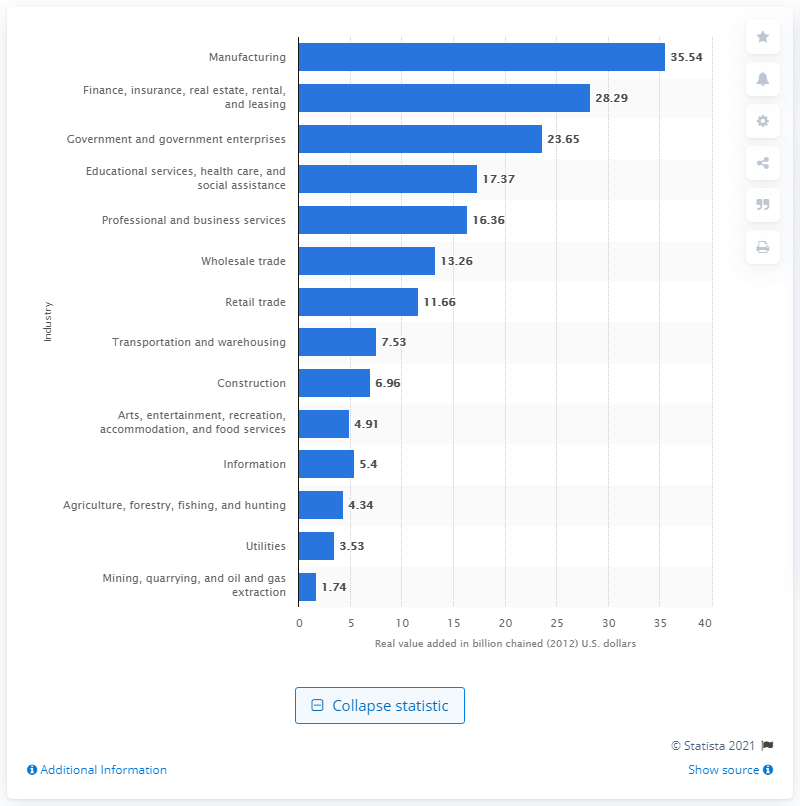What was the lowest contributing industry to Kentucky's GDP in 2020 and how does it compare to the top contributor? The lowest contributing industry to Kentucky's GDP in 2020 was the Mining, quarrying, and oil and gas extraction sector, at just 1.74 billion chained 2012 U.S. dollars. This is significantly lower compared to the top contributor, manufacturing, which added 35.54 billion, showcasing a stark contrast in economic impact between the industries. 